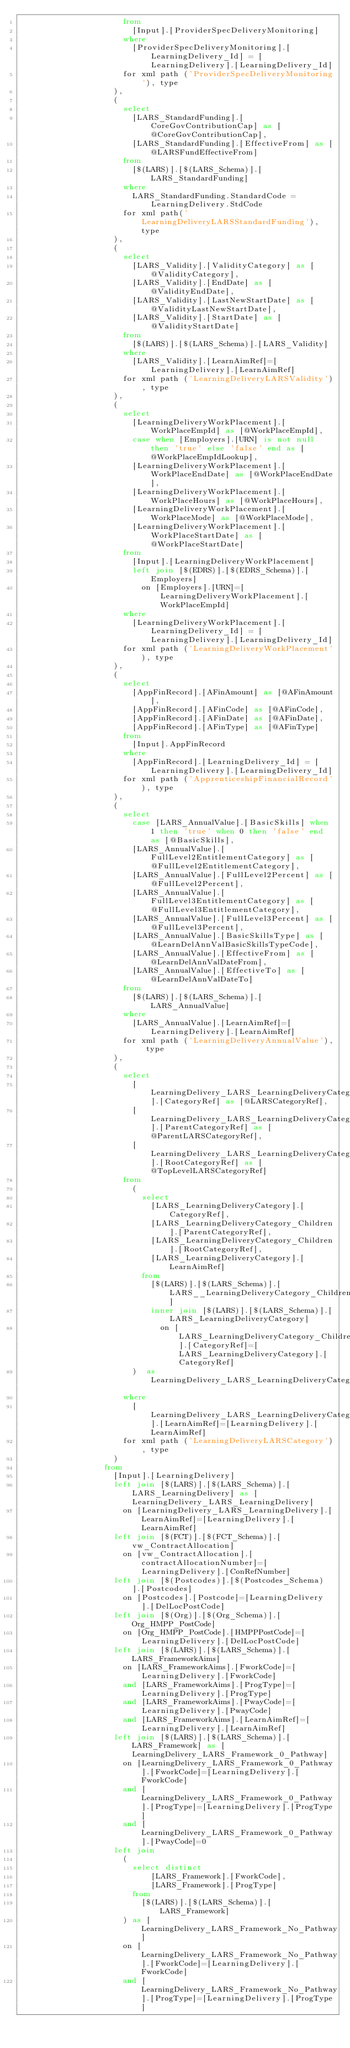<code> <loc_0><loc_0><loc_500><loc_500><_SQL_>											from
												[Input].[ProviderSpecDeliveryMonitoring]
											where
												[ProviderSpecDeliveryMonitoring].[LearningDelivery_Id] = [LearningDelivery].[LearningDelivery_Id]
											for xml path ('ProviderSpecDeliveryMonitoring'), type
										),
										(
											select
												[LARS_StandardFunding].[CoreGovContributionCap] as [@CoreGovContributionCap],
												[LARS_StandardFunding].[EffectiveFrom] as [@LARSFundEffectiveFrom]
											from
												[$(LARS)].[$(LARS_Schema)].[LARS_StandardFunding]
											where
												LARS_StandardFunding.StandardCode = LearningDelivery.StdCode
											for xml path('LearningDeliveryLARSStandardFunding'), type
										),
										(
											select
												[LARS_Validity].[ValidityCategory] as [@ValidityCategory],
												[LARS_Validity].[EndDate] as [@ValidityEndDate],
												[LARS_Validity].[LastNewStartDate] as [@ValidityLastNewStartDate],
												[LARS_Validity].[StartDate] as [@ValidityStartDate]
											from
												[$(LARS)].[$(LARS_Schema)].[LARS_Validity]
											where
												[LARS_Validity].[LearnAimRef]=[LearningDelivery].[LearnAimRef]
											for xml path ('LearningDeliveryLARSValidity'), type
										),
										(
											select
												[LearningDeliveryWorkPlacement].[WorkPlaceEmpId] as [@WorkPlaceEmpId],
												case when [Employers].[URN] is not null then 'true' else 'false' end as [@WorkPlaceEmpIdLookup],
												[LearningDeliveryWorkPlacement].[WorkPlaceEndDate] as [@WorkPlaceEndDate],
												[LearningDeliveryWorkPlacement].[WorkPlaceHours] as [@WorkPlaceHours],
												[LearningDeliveryWorkPlacement].[WorkPlaceMode] as [@WorkPlaceMode],
												[LearningDeliveryWorkPlacement].[WorkPlaceStartDate] as [@WorkPlaceStartDate]
											from
												[Input].[LearningDeliveryWorkPlacement]
												left join [$(EDRS)].[$(EDRS_Schema)].[Employers]
													on [Employers].[URN]=[LearningDeliveryWorkPlacement].[WorkPlaceEmpId]
											where
												[LearningDeliveryWorkPlacement].[LearningDelivery_Id] = [LearningDelivery].[LearningDelivery_Id]
											for xml path ('LearningDeliveryWorkPlacement'), type
										),
										(
											select
												[AppFinRecord].[AFinAmount] as [@AFinAmount],
												[AppFinRecord].[AFinCode] as [@AFinCode],
												[AppFinRecord].[AFinDate] as [@AFinDate],
												[AppFinRecord].[AFinType] as [@AFinType]
											from
												[Input].AppFinRecord
											where
												[AppFinRecord].[LearningDelivery_Id] = [LearningDelivery].[LearningDelivery_Id]
											for xml path ('ApprenticeshipFinancialRecord'), type
										),
										(
											select
												case [LARS_AnnualValue].[BasicSkills] when 1 then 'true' when 0 then 'false' end as [@BasicSkills],
												[LARS_AnnualValue].[FullLevel2EntitlementCategory] as [@FullLevel2EntitlementCategory],
												[LARS_AnnualValue].[FullLevel2Percent] as [@FullLevel2Percent],
												[LARS_AnnualValue].[FullLevel3EntitlementCategory] as [@FullLevel3EntitlementCategory],
												[LARS_AnnualValue].[FullLevel3Percent] as [@FullLevel3Percent],
												[LARS_AnnualValue].[BasicSkillsType] as [@LearnDelAnnValBasicSkillsTypeCode],
												[LARS_AnnualValue].[EffectiveFrom] as [@LearnDelAnnValDateFrom],
												[LARS_AnnualValue].[EffectiveTo] as [@LearnDelAnnValDateTo]
											from
												[$(LARS)].[$(LARS_Schema)].[LARS_AnnualValue]
											where
												[LARS_AnnualValue].[LearnAimRef]=[LearningDelivery].[LearnAimRef]
											for xml path ('LearningDeliveryAnnualValue'), type
										),
										(
											select
												[LearningDelivery_LARS_LearningDeliveryCategory_LARS_LearningDeliveryCategory_Children].[CategoryRef] as [@LARSCategoryRef],
												[LearningDelivery_LARS_LearningDeliveryCategory_LARS_LearningDeliveryCategory_Children].[ParentCategoryRef] as [@ParentLARSCategoryRef],
												[LearningDelivery_LARS_LearningDeliveryCategory_LARS_LearningDeliveryCategory_Children].[RootCategoryRef] as [@TopLevelLARSCategoryRef]
											from
												(
													select
														[LARS_LearningDeliveryCategory].[CategoryRef],
														[LARS_LearningDeliveryCategory_Children].[ParentCategoryRef],
														[LARS_LearningDeliveryCategory_Children].[RootCategoryRef],
														[LARS_LearningDeliveryCategory].[LearnAimRef]
													from
														[$(LARS)].[$(LARS_Schema)].[LARS__LearningDeliveryCategory_Children]
														inner join [$(LARS)].[$(LARS_Schema)].[LARS_LearningDeliveryCategory]
															on [LARS_LearningDeliveryCategory_Children].[CategoryRef]=[LARS_LearningDeliveryCategory].[CategoryRef]
												)  as LearningDelivery_LARS_LearningDeliveryCategory_LARS_LearningDeliveryCategory_Children
											where
												[LearningDelivery_LARS_LearningDeliveryCategory_LARS_LearningDeliveryCategory_Children].[LearnAimRef]=[LearningDelivery].[LearnAimRef]
											for xml path ('LearningDeliveryLARSCategory'), type
										)
									from
										[Input].[LearningDelivery]
										left join [$(LARS)].[$(LARS_Schema)].[LARS_LearningDelivery] as [LearningDelivery_LARS_LearningDelivery]
											on [LearningDelivery_LARS_LearningDelivery].[LearnAimRef]=[LearningDelivery].[LearnAimRef]
										left join [$(FCT)].[$(FCT_Schema)].[vw_ContractAllocation]
											on [vw_ContractAllocation].[contractAllocationNumber]=[LearningDelivery].[ConRefNumber]
										left join [$(Postcodes)].[$(Postcodes_Schema)].[Postcodes]
											on [Postcodes].[Postcode]=[LearningDelivery].[DelLocPostCode]
										left join [$(Org)].[$(Org_Schema)].[Org_HMPP_PostCode]
											on [Org_HMPP_PostCode].[HMPPPostCode]=[LearningDelivery].[DelLocPostCode]
										left join [$(LARS)].[$(LARS_Schema)].[LARS_FrameworkAims]
											on [LARS_FrameworkAims].[FworkCode]=[LearningDelivery].[FworkCode]
											and [LARS_FrameworkAims].[ProgType]=[LearningDelivery].[ProgType]
											and [LARS_FrameworkAims].[PwayCode]=[LearningDelivery].[PwayCode]
											and [LARS_FrameworkAims].[LearnAimRef]=[LearningDelivery].[LearnAimRef]
										left join [$(LARS)].[$(LARS_Schema)].[LARS_Framework] as [LearningDelivery_LARS_Framework_0_Pathway]
											on [LearningDelivery_LARS_Framework_0_Pathway].[FworkCode]=[LearningDelivery].[FworkCode]
											and [LearningDelivery_LARS_Framework_0_Pathway].[ProgType]=[LearningDelivery].[ProgType]
											and [LearningDelivery_LARS_Framework_0_Pathway].[PwayCode]=0
										left join
											(
												select distinct
														[LARS_Framework].[FworkCode],
														[LARS_Framework].[ProgType]
												from
													[$(LARS)].[$(LARS_Schema)].[LARS_Framework]
											) as [LearningDelivery_LARS_Framework_No_Pathway]
											on [LearningDelivery_LARS_Framework_No_Pathway].[FworkCode]=[LearningDelivery].[FworkCode]
											and [LearningDelivery_LARS_Framework_No_Pathway].[ProgType]=[LearningDelivery].[ProgType]</code> 